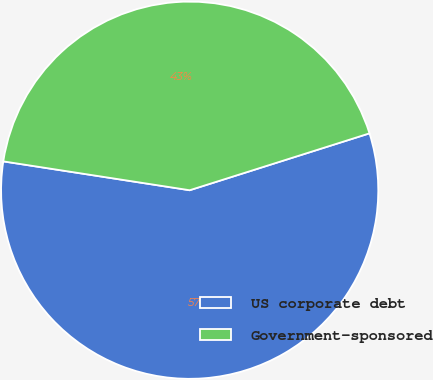Convert chart. <chart><loc_0><loc_0><loc_500><loc_500><pie_chart><fcel>US corporate debt<fcel>Government-sponsored<nl><fcel>57.32%<fcel>42.68%<nl></chart> 